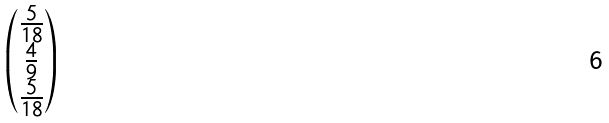Convert formula to latex. <formula><loc_0><loc_0><loc_500><loc_500>\begin{pmatrix} \frac { 5 } { 1 8 } \\ \frac { 4 } { 9 } \\ \frac { 5 } { 1 8 } \end{pmatrix}</formula> 